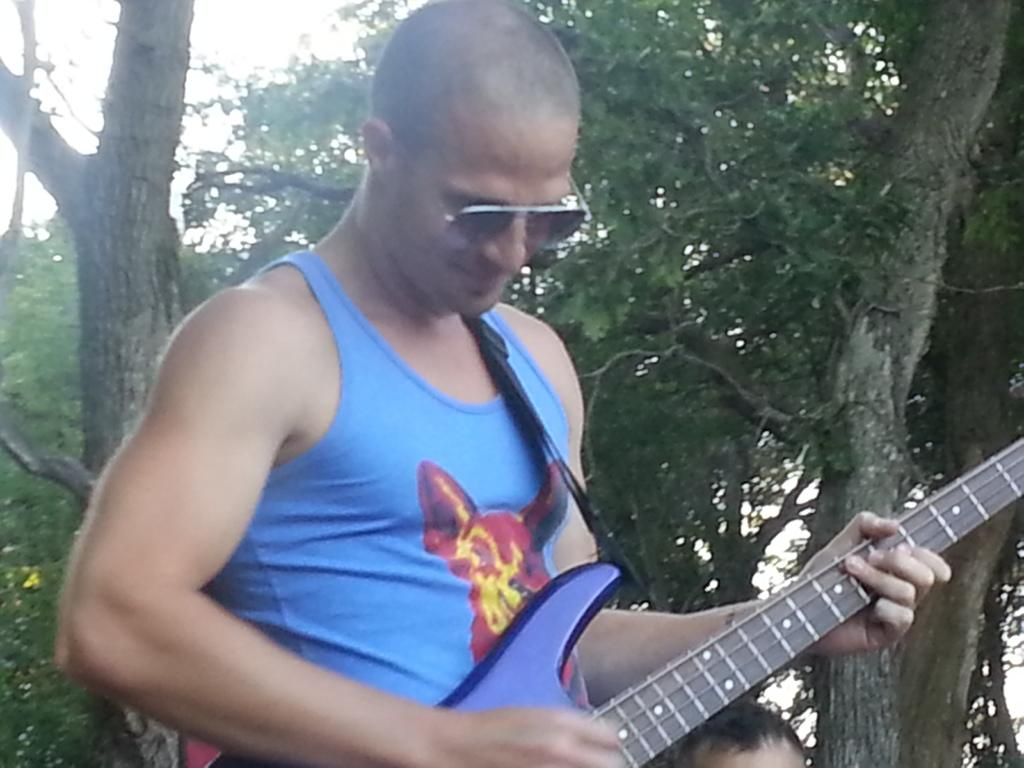What is the main subject of the image? There is a person standing in the image. What is the standing person doing? The person is playing a musical instrument. Can you describe the person sitting next to the standing person? There is a person sitting on the left side of the standing person. What can be seen in the background of the image? Trees and the sky are visible in the background of the image. What type of record is the person holding in the image? There is no record present in the image; the person is playing a musical instrument. What emotion does the doll in the image display? There is no doll present in the image. 